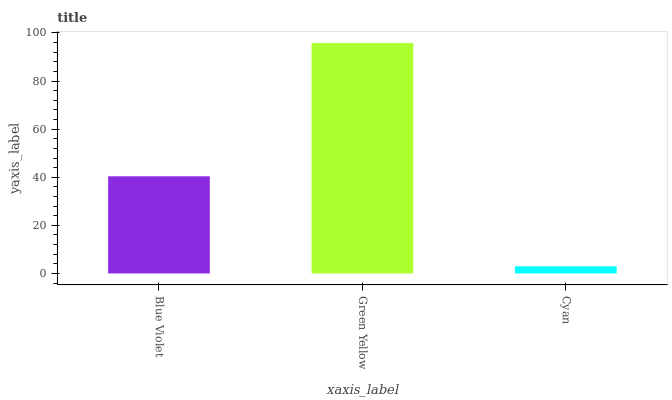Is Cyan the minimum?
Answer yes or no. Yes. Is Green Yellow the maximum?
Answer yes or no. Yes. Is Green Yellow the minimum?
Answer yes or no. No. Is Cyan the maximum?
Answer yes or no. No. Is Green Yellow greater than Cyan?
Answer yes or no. Yes. Is Cyan less than Green Yellow?
Answer yes or no. Yes. Is Cyan greater than Green Yellow?
Answer yes or no. No. Is Green Yellow less than Cyan?
Answer yes or no. No. Is Blue Violet the high median?
Answer yes or no. Yes. Is Blue Violet the low median?
Answer yes or no. Yes. Is Cyan the high median?
Answer yes or no. No. Is Cyan the low median?
Answer yes or no. No. 